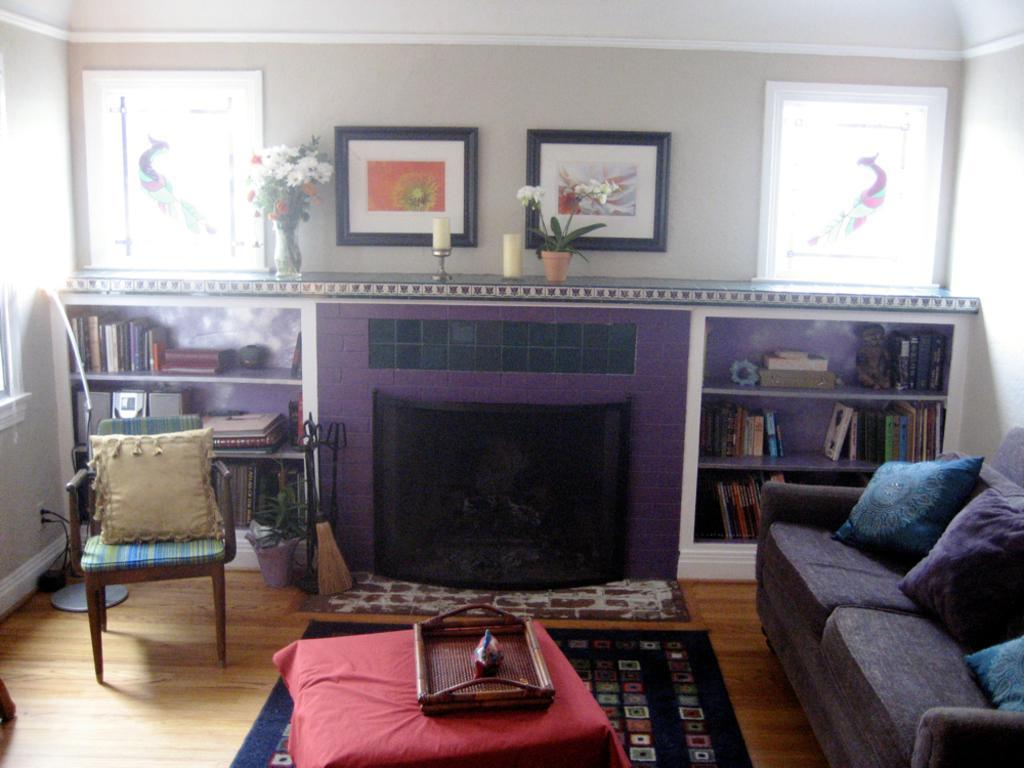Please provide a concise description of this image. In this picture we can see an inside view of a room, on the right side there is a couch, we can see three pillows on the couch, on the left side we can see a chair, there is a pillow on the chair, in the background there is a wall, we can see photo frames on the wall, there is a plant and a flower vase in the middle, on the right side and left side there are shelves, we can see some books on these shelves, there is a fireplace at the bottom. 